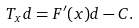Convert formula to latex. <formula><loc_0><loc_0><loc_500><loc_500>T _ { x } d = F ^ { \prime } ( x ) d - C .</formula> 